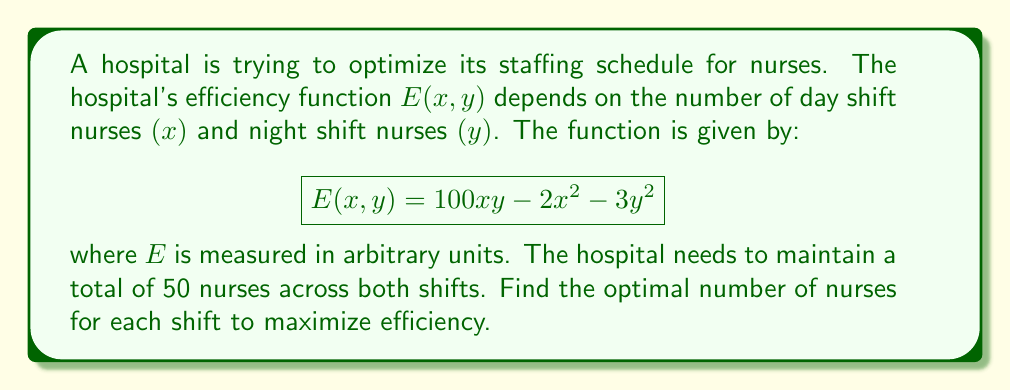Provide a solution to this math problem. To solve this optimization problem with a constraint, we'll use the method of Lagrange multipliers.

1) First, let's define our constraint function:
   $$g(x, y) = x + y - 50 = 0$$

2) Now, we form the Lagrangian function:
   $$L(x, y, \lambda) = E(x, y) - \lambda g(x, y)$$
   $$L(x, y, \lambda) = 100xy - 2x^2 - 3y^2 - \lambda(x + y - 50)$$

3) We find the partial derivatives and set them to zero:
   $$\frac{\partial L}{\partial x} = 100y - 4x - \lambda = 0$$
   $$\frac{\partial L}{\partial y} = 100x - 6y - \lambda = 0$$
   $$\frac{\partial L}{\partial \lambda} = -(x + y - 50) = 0$$

4) From the last equation, we confirm our constraint:
   $$x + y = 50$$

5) From the first two equations:
   $$100y - 4x = \lambda$$
   $$100x - 6y = \lambda$$

6) Equating these:
   $$100y - 4x = 100x - 6y$$
   $$106y = 104x$$
   $$y = \frac{52x}{53}$$

7) Substituting this into our constraint equation:
   $$x + \frac{52x}{53} = 50$$
   $$\frac{105x}{53} = 50$$
   $$x = \frac{2650}{105} = \frac{530}{21} \approx 25.24$$

8) Solving for y:
   $$y = 50 - x = 50 - \frac{530}{21} = \frac{520}{21} \approx 24.76$$

9) To confirm this is a maximum, we can check the second partial derivatives:
   $$\frac{\partial^2 E}{\partial x^2} = -4$$
   $$\frac{\partial^2 E}{\partial y^2} = -6$$
   $$\frac{\partial^2 E}{\partial x\partial y} = 100$$

   The Hessian determinant is positive, confirming a maximum.
Answer: The optimal staffing schedule to maximize efficiency is approximately 25 nurses for the day shift and 25 nurses for the night shift. 